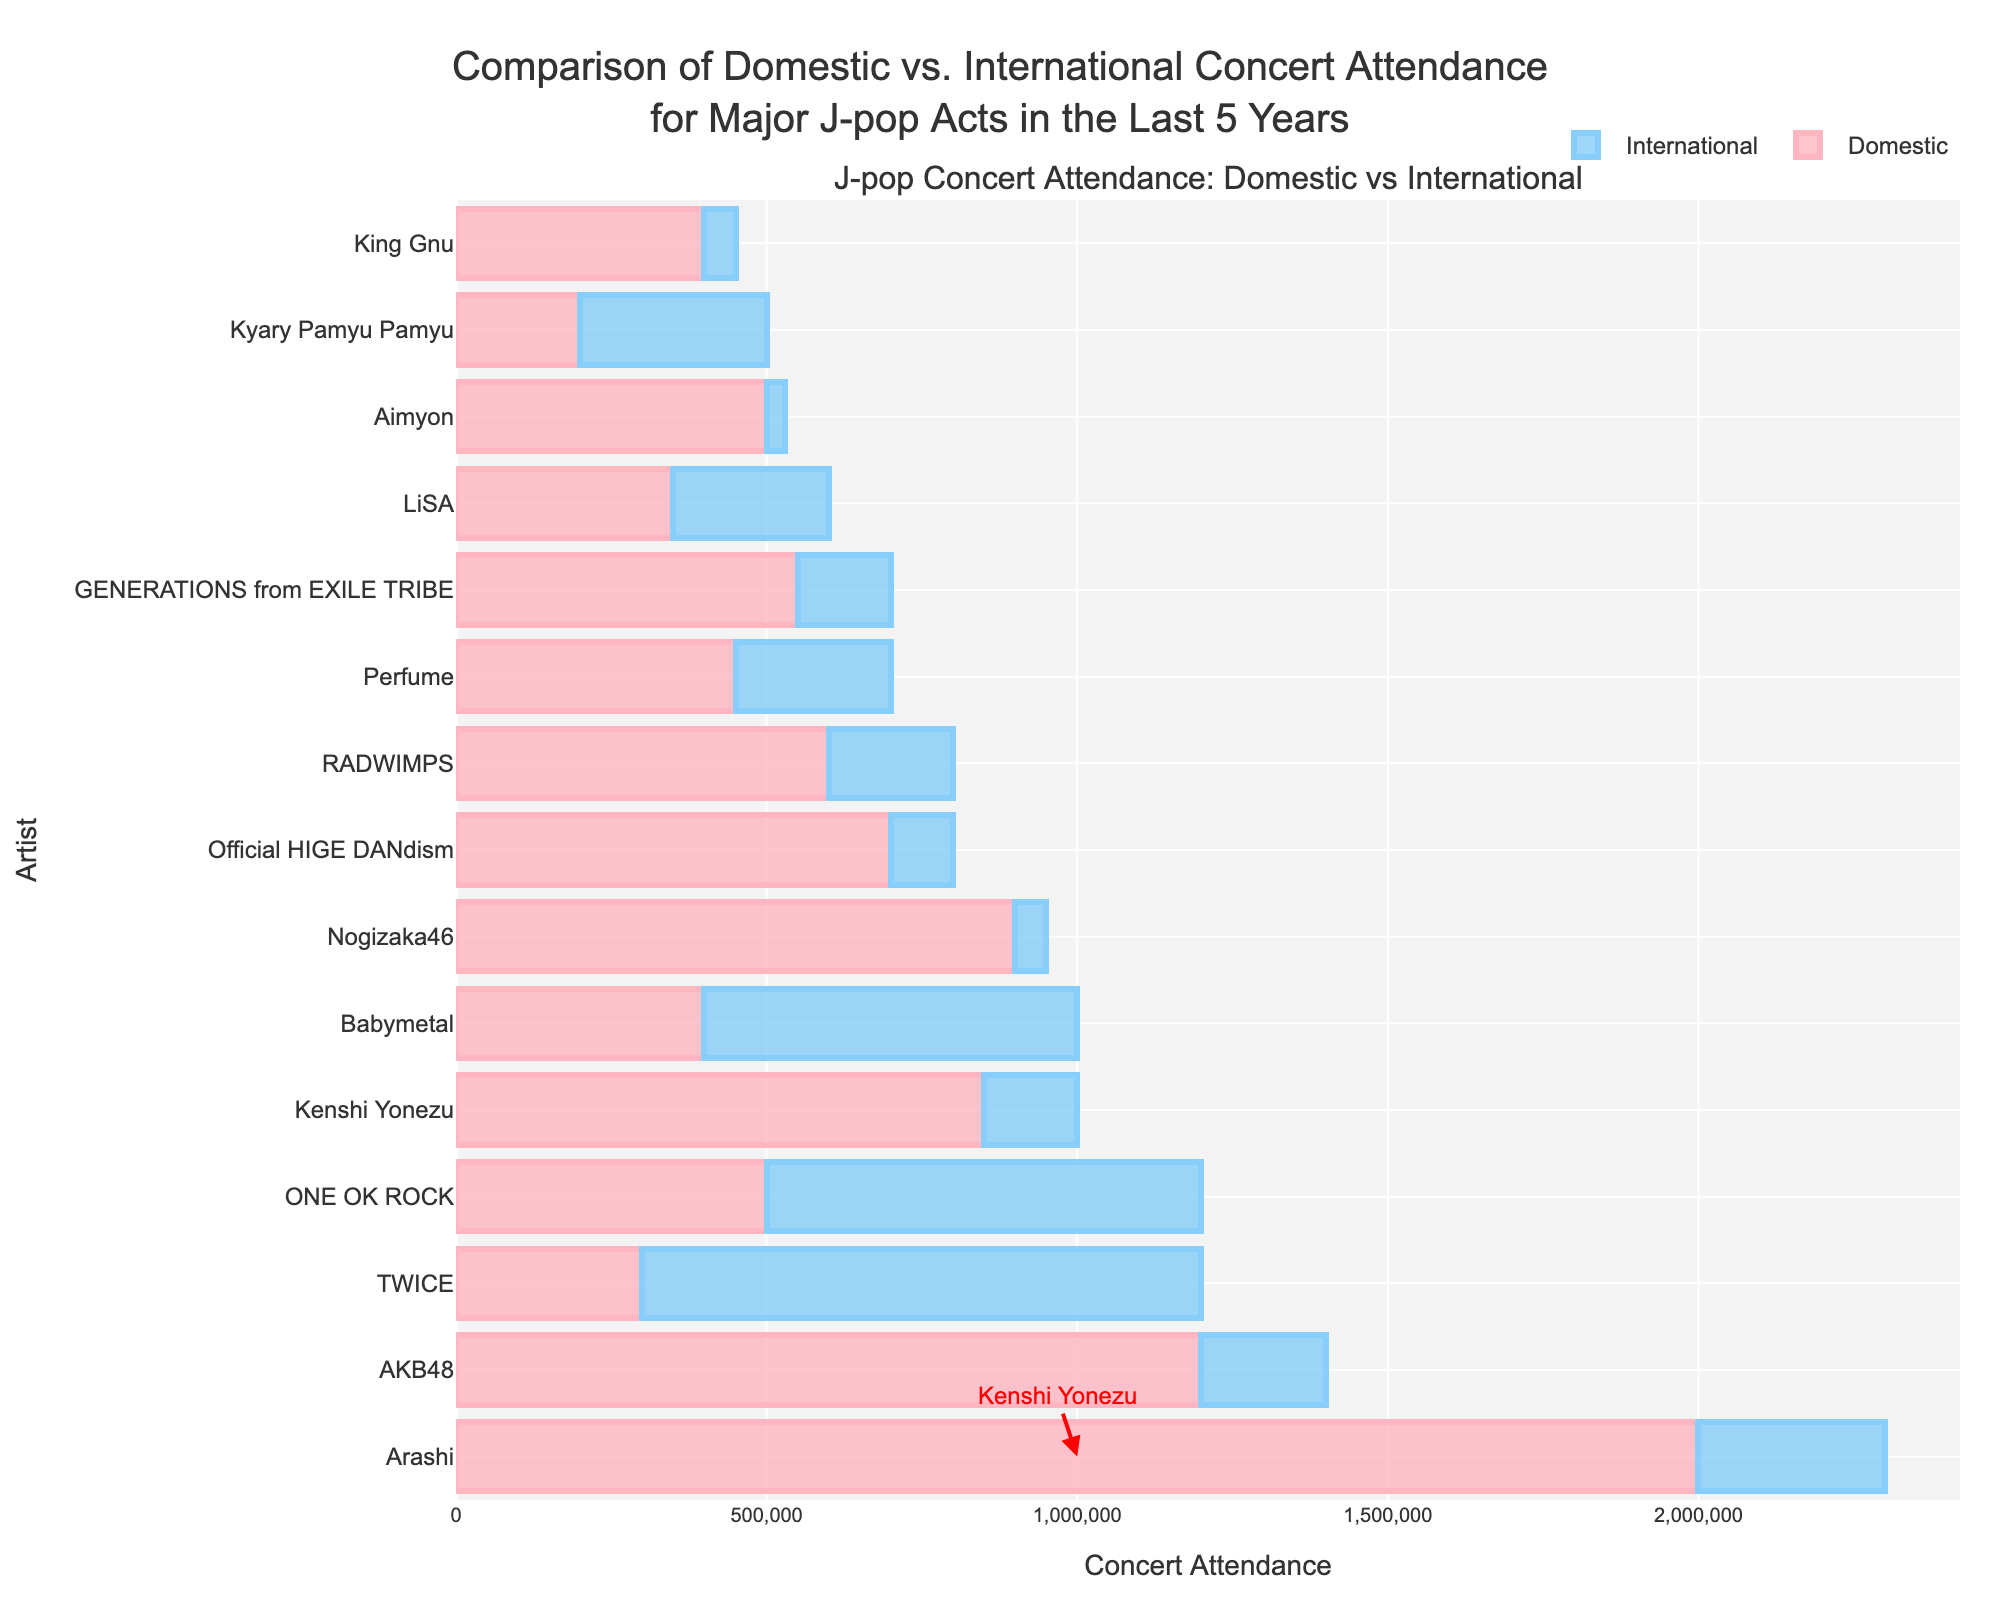What's the total concert attendance for Kenshi Yonezu? Kenshi Yonezu's total concert attendance is the sum of his domestic and international attendance. According to the data, domestic attendance is 850,000 and international attendance is 150,000. Summing these up, 850,000 + 150,000 = 1,000,000.
Answer: 1,000,000 Which artist has the highest domestic attendance? Refer to the figure to examine the lengths of the 'Domestic' bars for each artist. Arashi has the longest bar for 'Domestic Attendance', indicating they have the highest domestic concert attendance at 2,000,000.
Answer: Arashi Which artist has the higher ratio of international to domestic attendance, Babymetal or TWICE? To determine the ratio, divide international attendance by domestic attendance for each artist. For Babymetal, the ratio is 600,000/400,000 = 1.5. For TWICE, the ratio is 900,000/300,000 = 3. TWICE has a higher ratio.
Answer: TWICE What’s the difference in total attendance between the artist with the greatest and the least total attendance? First, identify the artists with the greatest and least total attendance. Arashi has the greatest total attendance of 2,300,000, and Aimyon has the least total attendance of 530,000. The difference is 2,300,000 - 530,000 = 1,770,000.
Answer: 1,770,000 Which artist has more total concert attendance, Kenshi Yonezu or AKB48? Kenshi Yonezu's total attendance is 1,000,000, while AKB48's total attendance is 1,400,000 (1,200,000 domestic + 200,000 international). AKB48 has more total attendance.
Answer: AKB48 How many artists have an international attendance greater than their domestic attendance? Review each artist's attendance. Babymetal and TWICE have higher international attendances compared to their domestic attendance, which means there are 2 artists.
Answer: 2 What is the average domestic attendance for all artists? Sum all the domestic attendances and divide by the number of artists. Total domestic attendance is (850,000 + 2,000,000 + 1,200,000 + 400,000 + 700,000 + 300,000 + 500,000 + 600,000 + 450,000 + 900,000 + 550,000 + 400,000 + 500,000 + 350,000 + 200,000) = 9,900,000. There are 15 artists, so the average is 9,900,000 / 15 = 660,000.
Answer: 660,000 Who has the least international concert attendance? By examining the 'International' section of the bars, Aimyon has the shortest bar for international attendance, which is 30,000.
Answer: Aimyon Which artist has a larger combined attendance, Perfume or LiSA? Perfume's total attendance is 700,000 (450,000 domestic + 250,000 international), and LiSA's total attendance is 600,000 (350,000 domestic + 250,000 international). Perfume has the larger combined attendance.
Answer: Perfume 